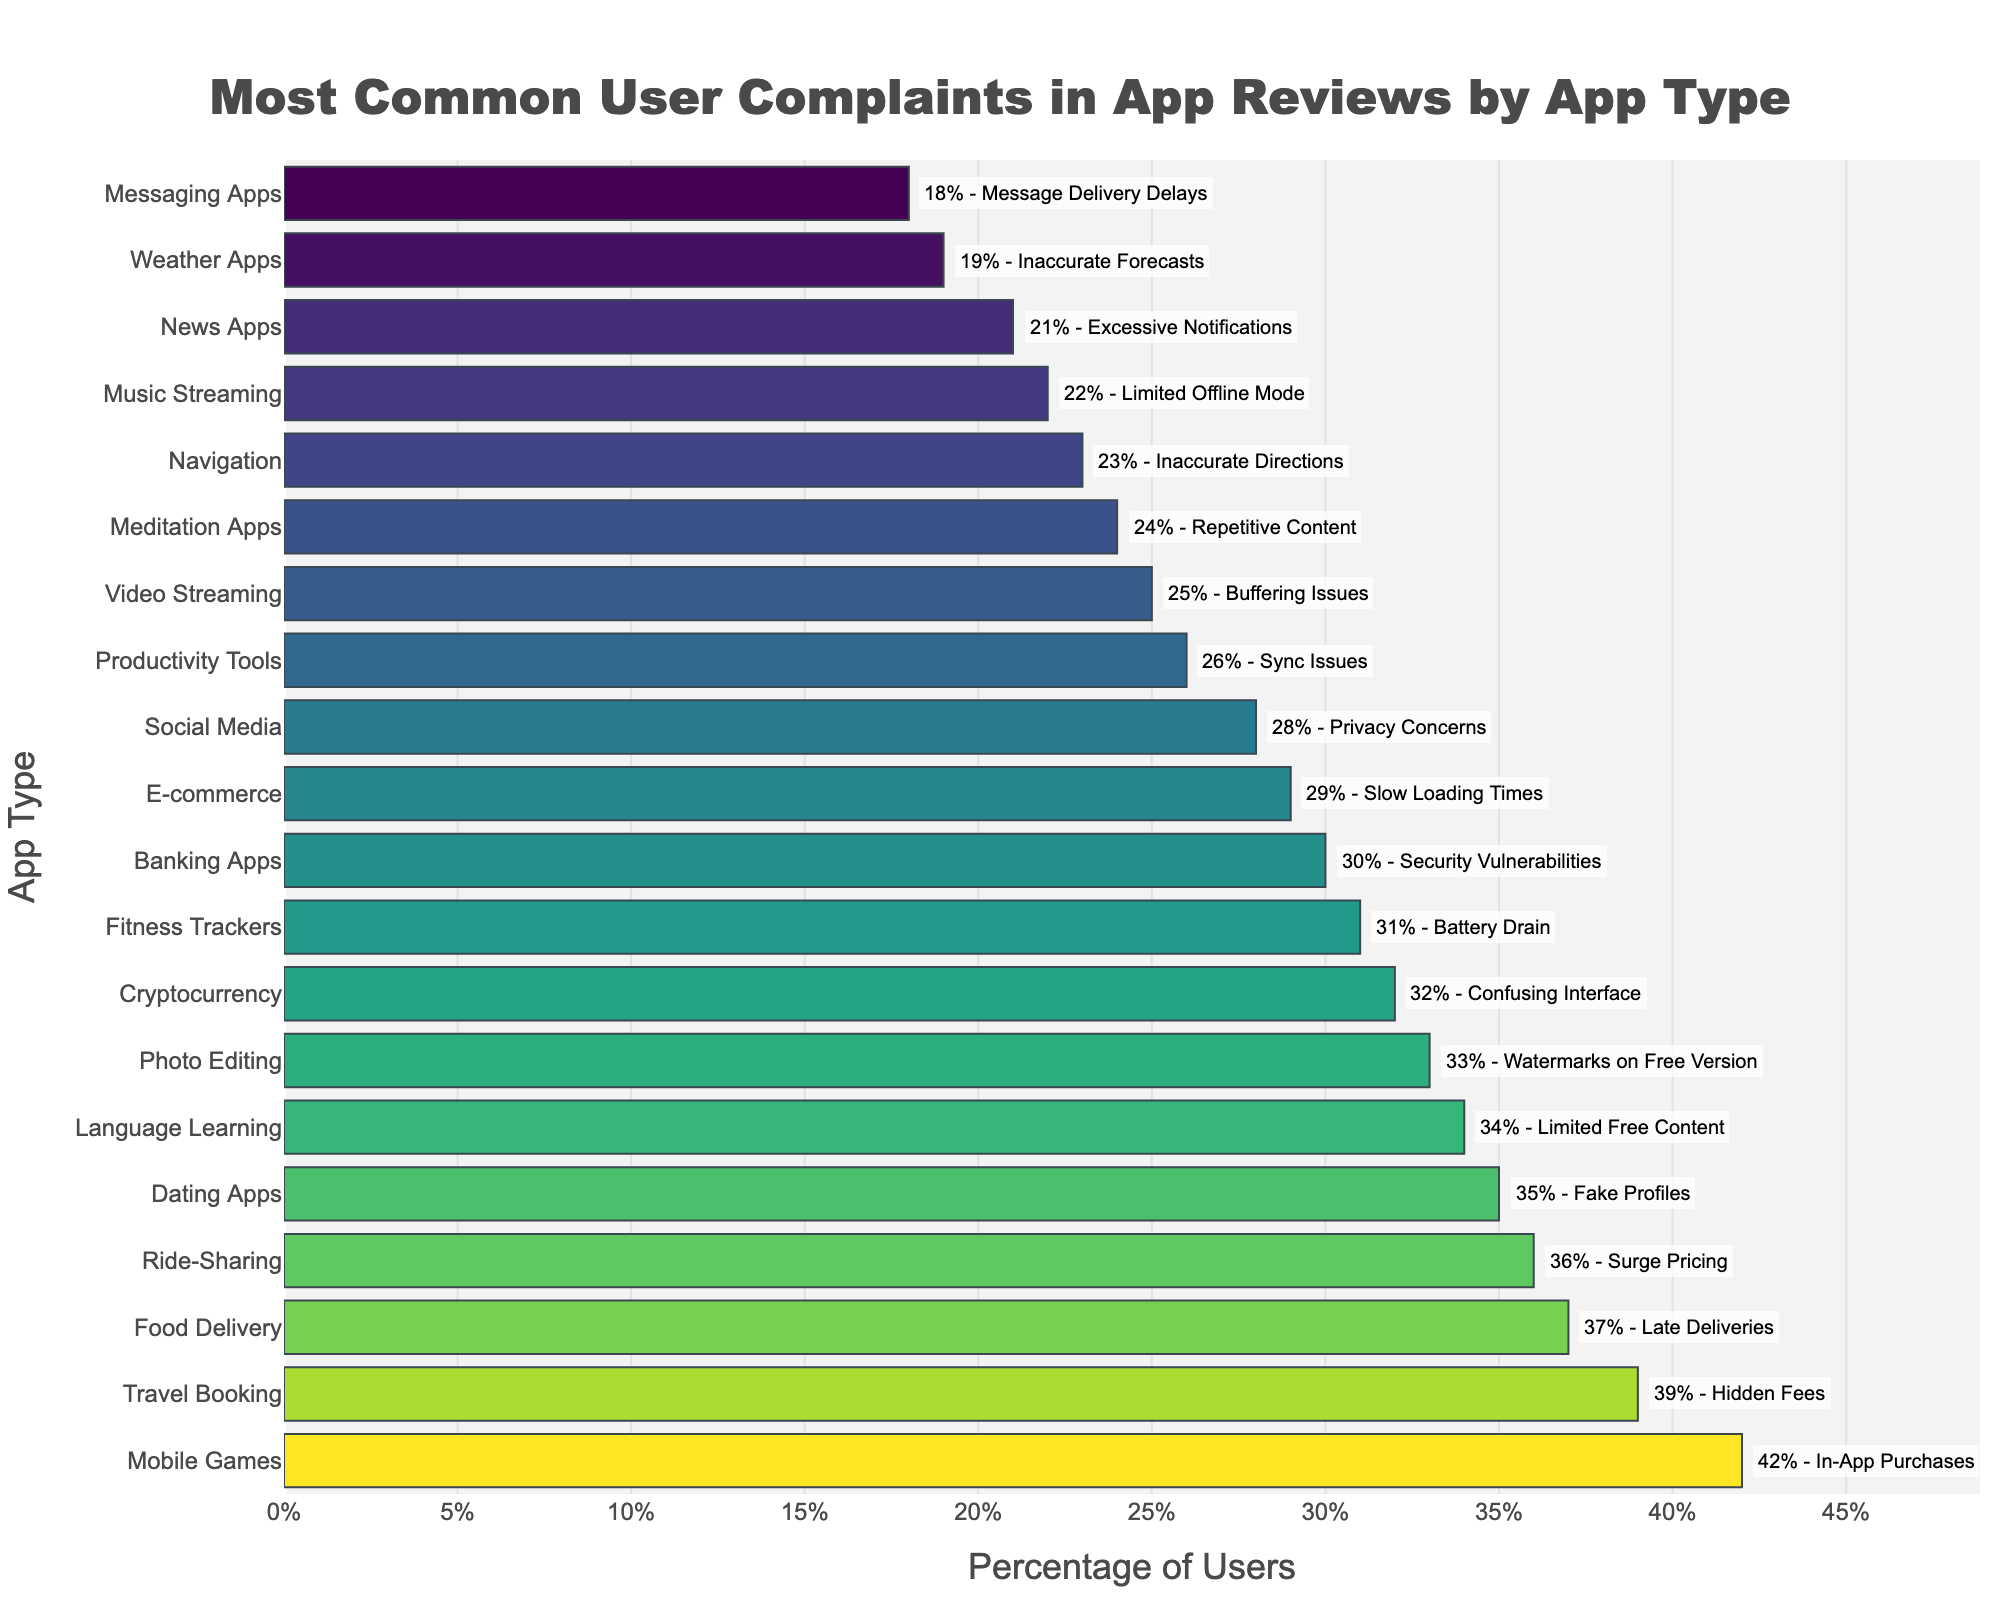Which app type has the highest percentage of user complaints? The bar chart shows the percentage of user complaints for different app types. The longest bar indicates the highest percentage, which corresponds to Mobile Games with 42%.
Answer: Mobile Games Which app type has the most complaints about security vulnerabilities, and what percentage is it? Look for the app type associated with security vulnerabilities on the bar chart and check its percentage. It is Banking Apps with 30%.
Answer: Banking Apps, 30% What is the percentage difference in complaints between Food Delivery apps and Weather Apps? Check the percentages for Food Delivery (37%) and Weather Apps (19%). Subtract the smaller percentage from the larger one: 37% - 19% = 18%.
Answer: 18% Which category has more complaints, Ride-Sharing or Cryptocurrency, and by how much? Compare the percentages of Ride-Sharing (36%) and Cryptocurrency (32%). The difference is 36% - 32% = 4%.
Answer: Ride-Sharing, 4% What is the average percentage of complaints for Social Media and Navigation apps? Add the percentages for Social Media (28%) and Navigation (23%), then divide by 2: (28% + 23%) / 2 = 25.5%.
Answer: 25.5% Which app type is closer in complaint percentage to Dating Apps: Fitness Trackers or Language Learning? Compare the percentages of Dating Apps (35%), Fitness Trackers (31%), and Language Learning (34%). Fitness Trackers have a 4% difference from Dating Apps, while Language Learning has a 1% difference.
Answer: Language Learning Are there any app types with similar complaint percentages to Meditation Apps? Check the percentage for Meditation Apps (24%) and look for similar percentages. Video Streaming has 25%, which is close.
Answer: Video Streaming What is the range of complaint percentages across all app types? Find the highest (Mobile Games, 42%) and lowest (Messaging Apps, 18%) percentages and calculate the range: 42% - 18% = 24%.
Answer: 24% How does the number of user complaints for Travel Booking apps compare against E-commerce apps? Check the percentages for Travel Booking (39%) and E-commerce (29%). Travel Booking apps have a higher complaint percentage.
Answer: Travel Booking apps have more complaints What is the total combined percentage of complaints for Banking Apps, Cryptocurrency, and Video Streaming? Add the percentages for Banking Apps (30%), Cryptocurrency (32%), and Video Streaming (25%): 30% + 32% + 25% = 87%.
Answer: 87% 